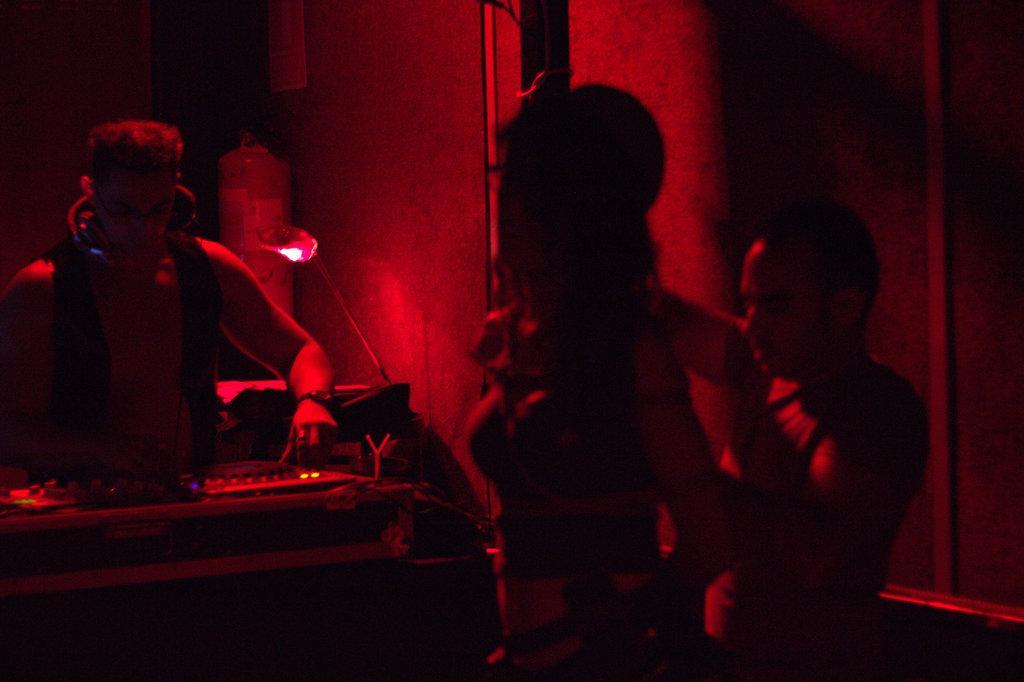How would you summarize this image in a sentence or two? In the picture I can see people, music system, a wall and some other objects. 